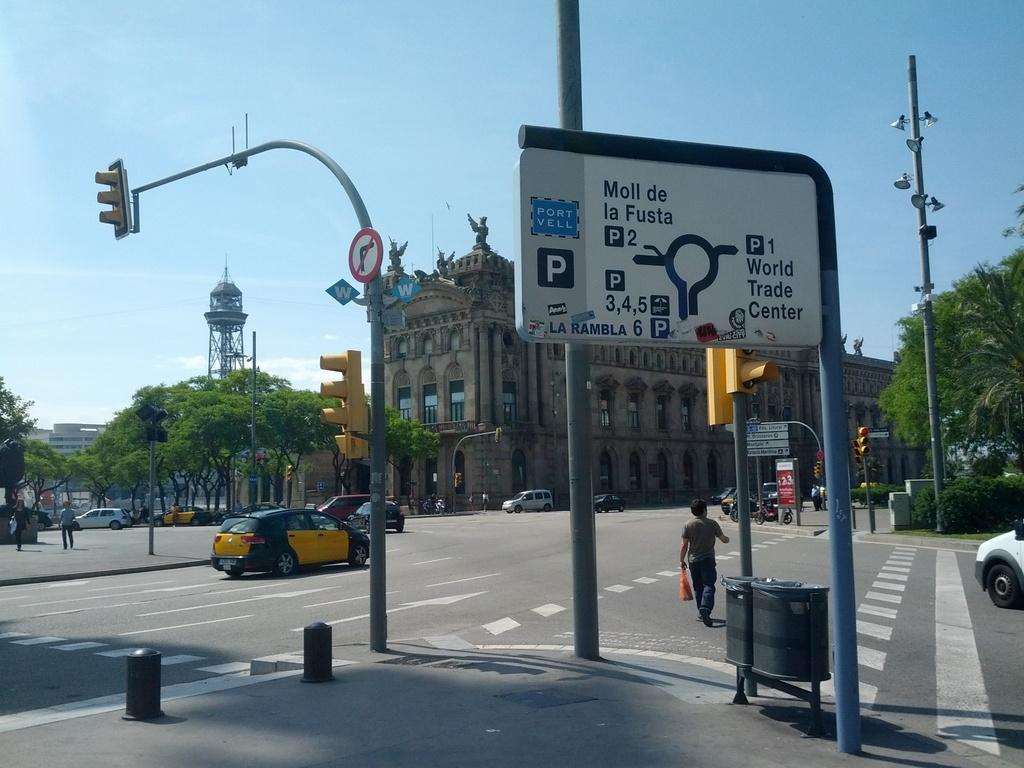<image>
Relay a brief, clear account of the picture shown. A parking information sign indicates a World Trade Center to the right. 